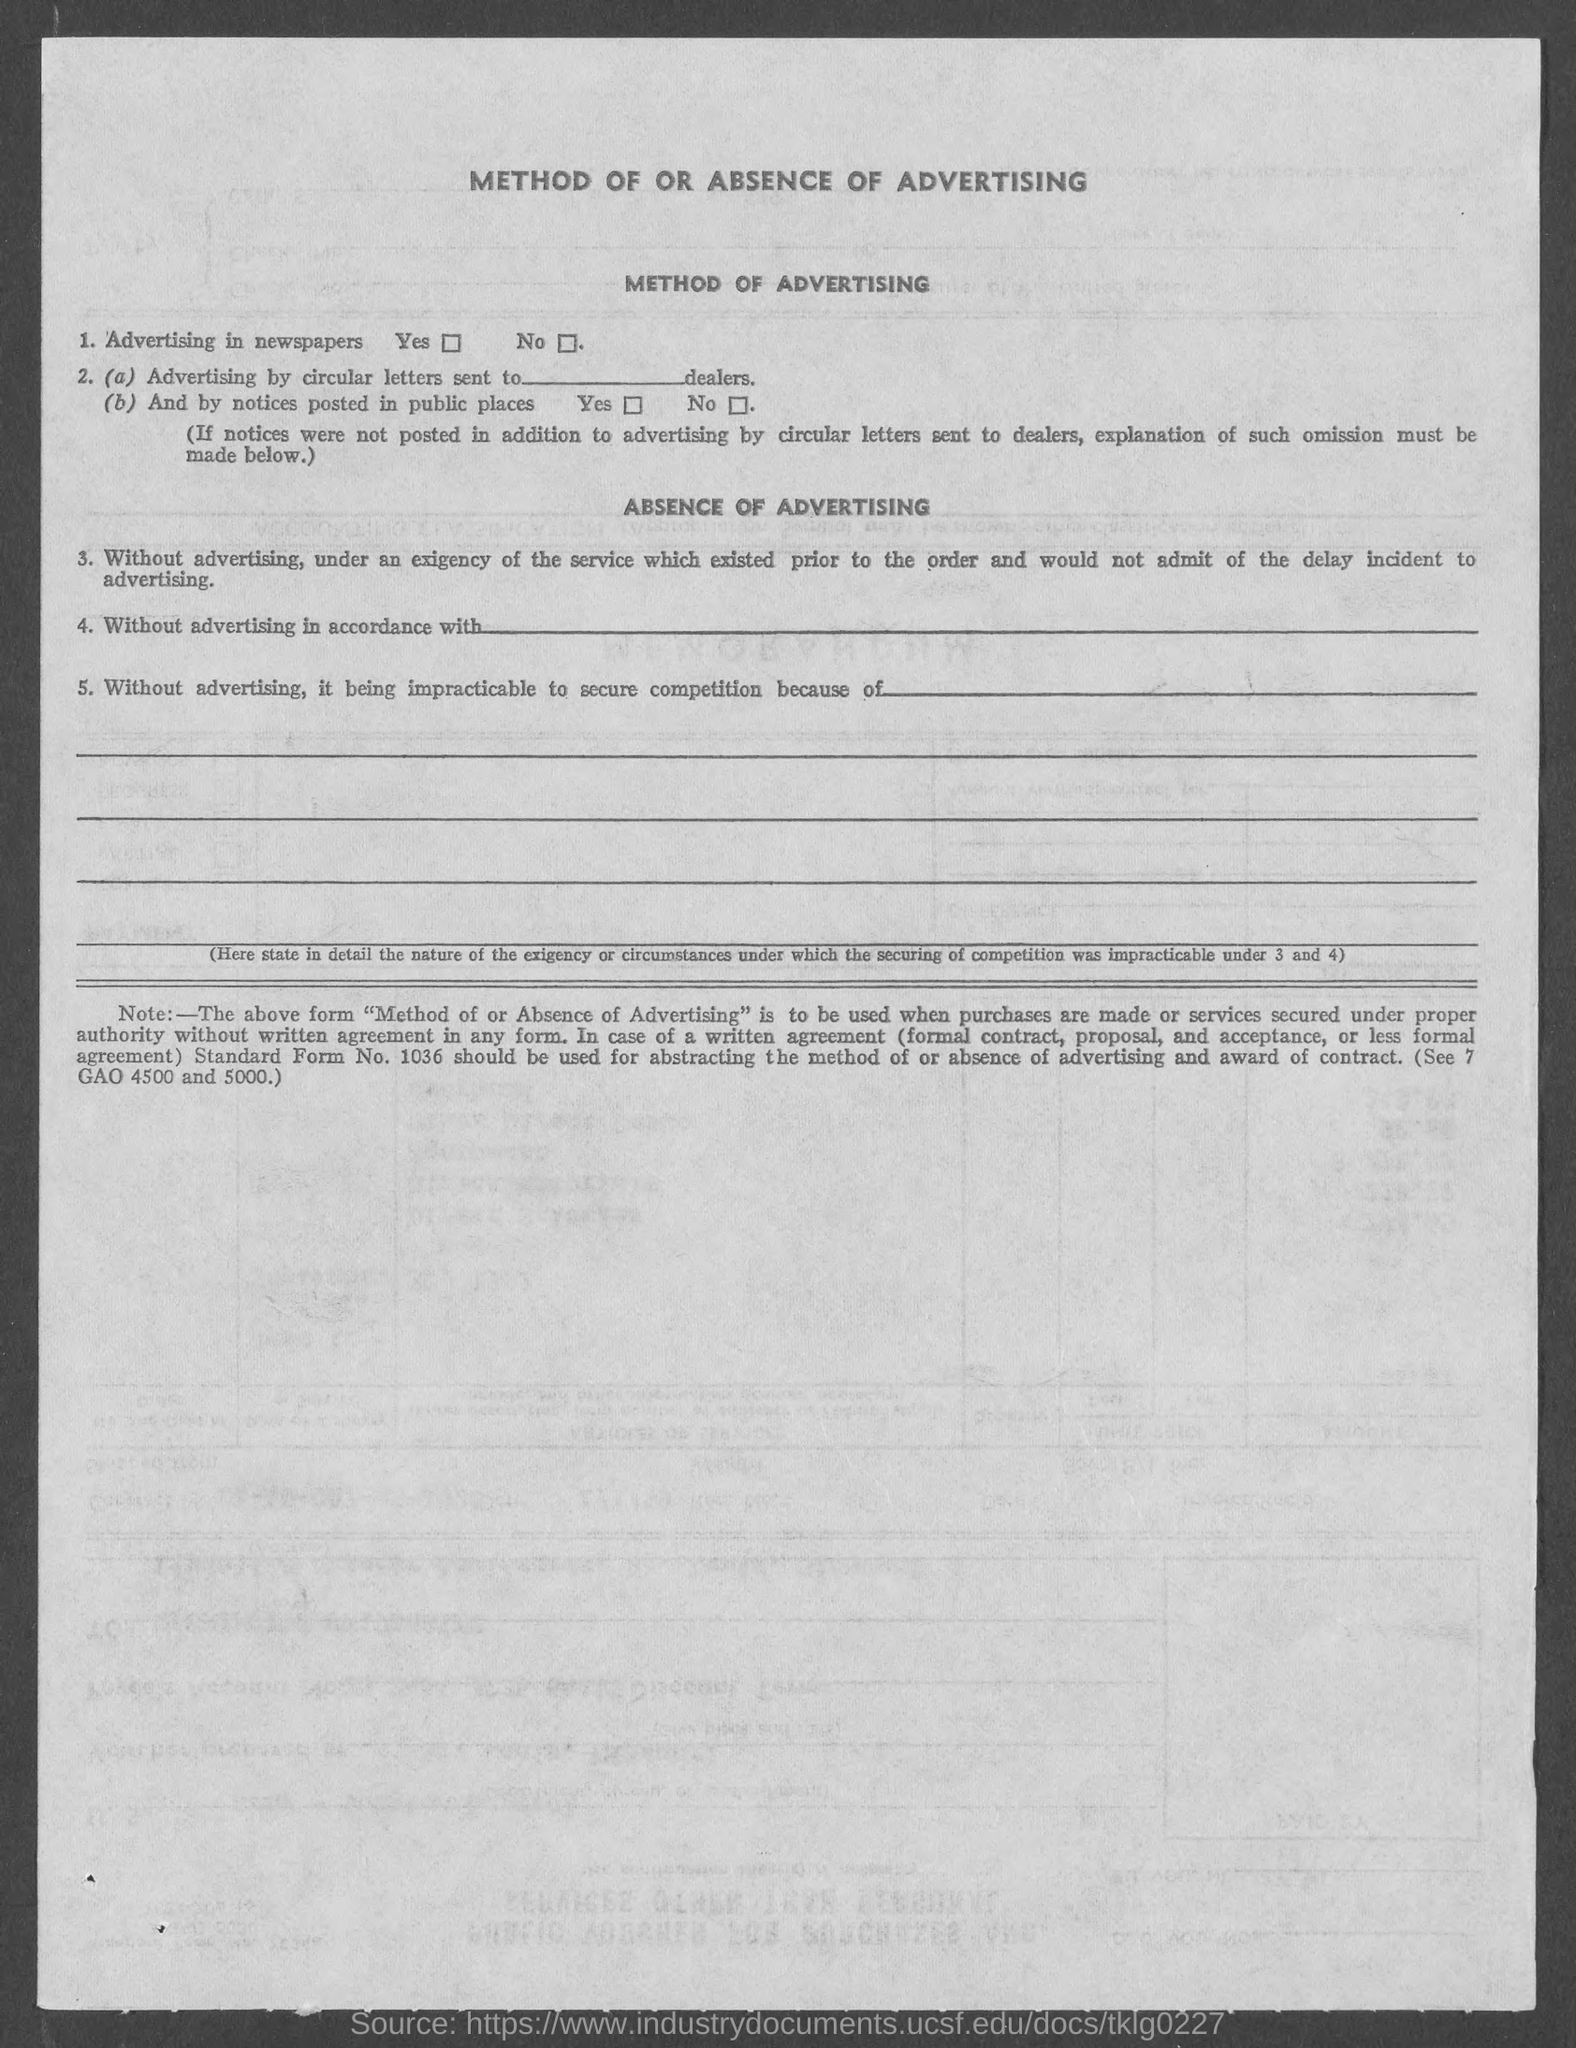What is the heading at top of the page?
Make the answer very short. Method of or absence of Advertising. 